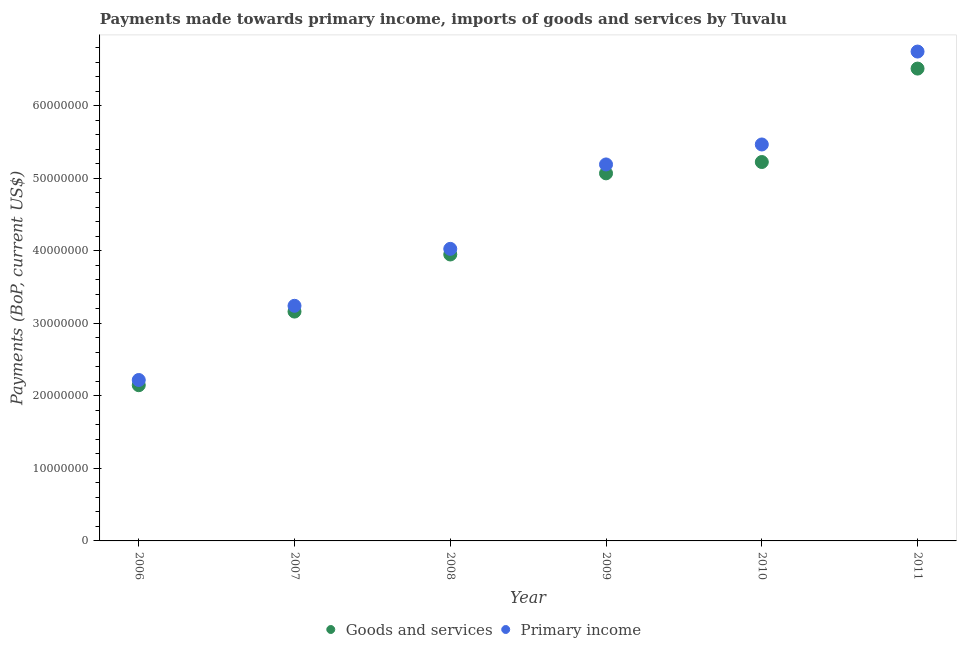How many different coloured dotlines are there?
Ensure brevity in your answer.  2. Is the number of dotlines equal to the number of legend labels?
Your answer should be very brief. Yes. What is the payments made towards primary income in 2007?
Provide a succinct answer. 3.24e+07. Across all years, what is the maximum payments made towards goods and services?
Your answer should be very brief. 6.51e+07. Across all years, what is the minimum payments made towards primary income?
Ensure brevity in your answer.  2.22e+07. In which year was the payments made towards goods and services maximum?
Provide a short and direct response. 2011. In which year was the payments made towards primary income minimum?
Offer a very short reply. 2006. What is the total payments made towards primary income in the graph?
Your answer should be compact. 2.69e+08. What is the difference between the payments made towards primary income in 2009 and that in 2011?
Ensure brevity in your answer.  -1.56e+07. What is the difference between the payments made towards primary income in 2007 and the payments made towards goods and services in 2008?
Keep it short and to the point. -7.08e+06. What is the average payments made towards primary income per year?
Your answer should be very brief. 4.48e+07. In the year 2007, what is the difference between the payments made towards primary income and payments made towards goods and services?
Provide a succinct answer. 7.97e+05. What is the ratio of the payments made towards primary income in 2008 to that in 2009?
Your response must be concise. 0.78. Is the payments made towards goods and services in 2006 less than that in 2010?
Your response must be concise. Yes. Is the difference between the payments made towards goods and services in 2006 and 2010 greater than the difference between the payments made towards primary income in 2006 and 2010?
Keep it short and to the point. Yes. What is the difference between the highest and the second highest payments made towards primary income?
Provide a short and direct response. 1.28e+07. What is the difference between the highest and the lowest payments made towards primary income?
Offer a terse response. 4.53e+07. Is the sum of the payments made towards goods and services in 2008 and 2011 greater than the maximum payments made towards primary income across all years?
Your answer should be compact. Yes. Does the payments made towards primary income monotonically increase over the years?
Offer a terse response. Yes. Is the payments made towards goods and services strictly greater than the payments made towards primary income over the years?
Offer a very short reply. No. What is the difference between two consecutive major ticks on the Y-axis?
Your answer should be very brief. 1.00e+07. Are the values on the major ticks of Y-axis written in scientific E-notation?
Keep it short and to the point. No. Does the graph contain any zero values?
Provide a short and direct response. No. How many legend labels are there?
Keep it short and to the point. 2. What is the title of the graph?
Your response must be concise. Payments made towards primary income, imports of goods and services by Tuvalu. What is the label or title of the Y-axis?
Make the answer very short. Payments (BoP, current US$). What is the Payments (BoP, current US$) of Goods and services in 2006?
Keep it short and to the point. 2.15e+07. What is the Payments (BoP, current US$) in Primary income in 2006?
Your answer should be very brief. 2.22e+07. What is the Payments (BoP, current US$) in Goods and services in 2007?
Your response must be concise. 3.16e+07. What is the Payments (BoP, current US$) of Primary income in 2007?
Provide a succinct answer. 3.24e+07. What is the Payments (BoP, current US$) of Goods and services in 2008?
Your answer should be very brief. 3.95e+07. What is the Payments (BoP, current US$) of Primary income in 2008?
Provide a succinct answer. 4.03e+07. What is the Payments (BoP, current US$) of Goods and services in 2009?
Provide a short and direct response. 5.07e+07. What is the Payments (BoP, current US$) of Primary income in 2009?
Ensure brevity in your answer.  5.19e+07. What is the Payments (BoP, current US$) in Goods and services in 2010?
Your answer should be compact. 5.22e+07. What is the Payments (BoP, current US$) of Primary income in 2010?
Offer a very short reply. 5.47e+07. What is the Payments (BoP, current US$) of Goods and services in 2011?
Give a very brief answer. 6.51e+07. What is the Payments (BoP, current US$) in Primary income in 2011?
Your answer should be compact. 6.75e+07. Across all years, what is the maximum Payments (BoP, current US$) in Goods and services?
Keep it short and to the point. 6.51e+07. Across all years, what is the maximum Payments (BoP, current US$) in Primary income?
Make the answer very short. 6.75e+07. Across all years, what is the minimum Payments (BoP, current US$) in Goods and services?
Provide a short and direct response. 2.15e+07. Across all years, what is the minimum Payments (BoP, current US$) of Primary income?
Give a very brief answer. 2.22e+07. What is the total Payments (BoP, current US$) of Goods and services in the graph?
Make the answer very short. 2.61e+08. What is the total Payments (BoP, current US$) of Primary income in the graph?
Provide a short and direct response. 2.69e+08. What is the difference between the Payments (BoP, current US$) of Goods and services in 2006 and that in 2007?
Make the answer very short. -1.02e+07. What is the difference between the Payments (BoP, current US$) in Primary income in 2006 and that in 2007?
Ensure brevity in your answer.  -1.02e+07. What is the difference between the Payments (BoP, current US$) in Goods and services in 2006 and that in 2008?
Make the answer very short. -1.80e+07. What is the difference between the Payments (BoP, current US$) of Primary income in 2006 and that in 2008?
Provide a succinct answer. -1.81e+07. What is the difference between the Payments (BoP, current US$) in Goods and services in 2006 and that in 2009?
Your answer should be very brief. -2.92e+07. What is the difference between the Payments (BoP, current US$) of Primary income in 2006 and that in 2009?
Provide a succinct answer. -2.97e+07. What is the difference between the Payments (BoP, current US$) in Goods and services in 2006 and that in 2010?
Keep it short and to the point. -3.08e+07. What is the difference between the Payments (BoP, current US$) in Primary income in 2006 and that in 2010?
Your response must be concise. -3.25e+07. What is the difference between the Payments (BoP, current US$) in Goods and services in 2006 and that in 2011?
Offer a very short reply. -4.37e+07. What is the difference between the Payments (BoP, current US$) in Primary income in 2006 and that in 2011?
Offer a terse response. -4.53e+07. What is the difference between the Payments (BoP, current US$) in Goods and services in 2007 and that in 2008?
Provide a short and direct response. -7.87e+06. What is the difference between the Payments (BoP, current US$) of Primary income in 2007 and that in 2008?
Your answer should be compact. -7.85e+06. What is the difference between the Payments (BoP, current US$) in Goods and services in 2007 and that in 2009?
Provide a succinct answer. -1.91e+07. What is the difference between the Payments (BoP, current US$) of Primary income in 2007 and that in 2009?
Provide a succinct answer. -1.95e+07. What is the difference between the Payments (BoP, current US$) in Goods and services in 2007 and that in 2010?
Provide a short and direct response. -2.06e+07. What is the difference between the Payments (BoP, current US$) in Primary income in 2007 and that in 2010?
Provide a succinct answer. -2.22e+07. What is the difference between the Payments (BoP, current US$) in Goods and services in 2007 and that in 2011?
Your answer should be very brief. -3.35e+07. What is the difference between the Payments (BoP, current US$) of Primary income in 2007 and that in 2011?
Your response must be concise. -3.51e+07. What is the difference between the Payments (BoP, current US$) in Goods and services in 2008 and that in 2009?
Offer a very short reply. -1.12e+07. What is the difference between the Payments (BoP, current US$) of Primary income in 2008 and that in 2009?
Offer a very short reply. -1.16e+07. What is the difference between the Payments (BoP, current US$) in Goods and services in 2008 and that in 2010?
Give a very brief answer. -1.27e+07. What is the difference between the Payments (BoP, current US$) of Primary income in 2008 and that in 2010?
Your answer should be very brief. -1.44e+07. What is the difference between the Payments (BoP, current US$) of Goods and services in 2008 and that in 2011?
Provide a succinct answer. -2.56e+07. What is the difference between the Payments (BoP, current US$) of Primary income in 2008 and that in 2011?
Your answer should be very brief. -2.72e+07. What is the difference between the Payments (BoP, current US$) in Goods and services in 2009 and that in 2010?
Provide a short and direct response. -1.56e+06. What is the difference between the Payments (BoP, current US$) of Primary income in 2009 and that in 2010?
Provide a short and direct response. -2.75e+06. What is the difference between the Payments (BoP, current US$) in Goods and services in 2009 and that in 2011?
Your answer should be compact. -1.44e+07. What is the difference between the Payments (BoP, current US$) of Primary income in 2009 and that in 2011?
Offer a very short reply. -1.56e+07. What is the difference between the Payments (BoP, current US$) in Goods and services in 2010 and that in 2011?
Keep it short and to the point. -1.29e+07. What is the difference between the Payments (BoP, current US$) in Primary income in 2010 and that in 2011?
Offer a terse response. -1.28e+07. What is the difference between the Payments (BoP, current US$) of Goods and services in 2006 and the Payments (BoP, current US$) of Primary income in 2007?
Your answer should be compact. -1.09e+07. What is the difference between the Payments (BoP, current US$) in Goods and services in 2006 and the Payments (BoP, current US$) in Primary income in 2008?
Keep it short and to the point. -1.88e+07. What is the difference between the Payments (BoP, current US$) of Goods and services in 2006 and the Payments (BoP, current US$) of Primary income in 2009?
Your response must be concise. -3.04e+07. What is the difference between the Payments (BoP, current US$) of Goods and services in 2006 and the Payments (BoP, current US$) of Primary income in 2010?
Provide a short and direct response. -3.32e+07. What is the difference between the Payments (BoP, current US$) in Goods and services in 2006 and the Payments (BoP, current US$) in Primary income in 2011?
Offer a terse response. -4.60e+07. What is the difference between the Payments (BoP, current US$) in Goods and services in 2007 and the Payments (BoP, current US$) in Primary income in 2008?
Keep it short and to the point. -8.65e+06. What is the difference between the Payments (BoP, current US$) of Goods and services in 2007 and the Payments (BoP, current US$) of Primary income in 2009?
Make the answer very short. -2.03e+07. What is the difference between the Payments (BoP, current US$) of Goods and services in 2007 and the Payments (BoP, current US$) of Primary income in 2010?
Provide a short and direct response. -2.30e+07. What is the difference between the Payments (BoP, current US$) in Goods and services in 2007 and the Payments (BoP, current US$) in Primary income in 2011?
Your response must be concise. -3.59e+07. What is the difference between the Payments (BoP, current US$) in Goods and services in 2008 and the Payments (BoP, current US$) in Primary income in 2009?
Ensure brevity in your answer.  -1.24e+07. What is the difference between the Payments (BoP, current US$) of Goods and services in 2008 and the Payments (BoP, current US$) of Primary income in 2010?
Offer a very short reply. -1.52e+07. What is the difference between the Payments (BoP, current US$) in Goods and services in 2008 and the Payments (BoP, current US$) in Primary income in 2011?
Provide a short and direct response. -2.80e+07. What is the difference between the Payments (BoP, current US$) in Goods and services in 2009 and the Payments (BoP, current US$) in Primary income in 2010?
Offer a very short reply. -3.98e+06. What is the difference between the Payments (BoP, current US$) of Goods and services in 2009 and the Payments (BoP, current US$) of Primary income in 2011?
Offer a very short reply. -1.68e+07. What is the difference between the Payments (BoP, current US$) of Goods and services in 2010 and the Payments (BoP, current US$) of Primary income in 2011?
Keep it short and to the point. -1.52e+07. What is the average Payments (BoP, current US$) of Goods and services per year?
Give a very brief answer. 4.34e+07. What is the average Payments (BoP, current US$) of Primary income per year?
Your response must be concise. 4.48e+07. In the year 2006, what is the difference between the Payments (BoP, current US$) in Goods and services and Payments (BoP, current US$) in Primary income?
Ensure brevity in your answer.  -7.17e+05. In the year 2007, what is the difference between the Payments (BoP, current US$) of Goods and services and Payments (BoP, current US$) of Primary income?
Make the answer very short. -7.97e+05. In the year 2008, what is the difference between the Payments (BoP, current US$) in Goods and services and Payments (BoP, current US$) in Primary income?
Offer a very short reply. -7.76e+05. In the year 2009, what is the difference between the Payments (BoP, current US$) of Goods and services and Payments (BoP, current US$) of Primary income?
Make the answer very short. -1.23e+06. In the year 2010, what is the difference between the Payments (BoP, current US$) of Goods and services and Payments (BoP, current US$) of Primary income?
Keep it short and to the point. -2.42e+06. In the year 2011, what is the difference between the Payments (BoP, current US$) of Goods and services and Payments (BoP, current US$) of Primary income?
Offer a very short reply. -2.35e+06. What is the ratio of the Payments (BoP, current US$) of Goods and services in 2006 to that in 2007?
Your response must be concise. 0.68. What is the ratio of the Payments (BoP, current US$) in Primary income in 2006 to that in 2007?
Ensure brevity in your answer.  0.68. What is the ratio of the Payments (BoP, current US$) of Goods and services in 2006 to that in 2008?
Your response must be concise. 0.54. What is the ratio of the Payments (BoP, current US$) of Primary income in 2006 to that in 2008?
Provide a succinct answer. 0.55. What is the ratio of the Payments (BoP, current US$) in Goods and services in 2006 to that in 2009?
Provide a succinct answer. 0.42. What is the ratio of the Payments (BoP, current US$) in Primary income in 2006 to that in 2009?
Provide a succinct answer. 0.43. What is the ratio of the Payments (BoP, current US$) of Goods and services in 2006 to that in 2010?
Give a very brief answer. 0.41. What is the ratio of the Payments (BoP, current US$) in Primary income in 2006 to that in 2010?
Give a very brief answer. 0.41. What is the ratio of the Payments (BoP, current US$) in Goods and services in 2006 to that in 2011?
Give a very brief answer. 0.33. What is the ratio of the Payments (BoP, current US$) of Primary income in 2006 to that in 2011?
Offer a very short reply. 0.33. What is the ratio of the Payments (BoP, current US$) in Goods and services in 2007 to that in 2008?
Make the answer very short. 0.8. What is the ratio of the Payments (BoP, current US$) in Primary income in 2007 to that in 2008?
Keep it short and to the point. 0.81. What is the ratio of the Payments (BoP, current US$) of Goods and services in 2007 to that in 2009?
Keep it short and to the point. 0.62. What is the ratio of the Payments (BoP, current US$) of Primary income in 2007 to that in 2009?
Make the answer very short. 0.62. What is the ratio of the Payments (BoP, current US$) of Goods and services in 2007 to that in 2010?
Offer a very short reply. 0.61. What is the ratio of the Payments (BoP, current US$) in Primary income in 2007 to that in 2010?
Your answer should be very brief. 0.59. What is the ratio of the Payments (BoP, current US$) of Goods and services in 2007 to that in 2011?
Offer a terse response. 0.49. What is the ratio of the Payments (BoP, current US$) in Primary income in 2007 to that in 2011?
Your answer should be very brief. 0.48. What is the ratio of the Payments (BoP, current US$) of Goods and services in 2008 to that in 2009?
Offer a very short reply. 0.78. What is the ratio of the Payments (BoP, current US$) in Primary income in 2008 to that in 2009?
Your answer should be compact. 0.78. What is the ratio of the Payments (BoP, current US$) of Goods and services in 2008 to that in 2010?
Offer a very short reply. 0.76. What is the ratio of the Payments (BoP, current US$) of Primary income in 2008 to that in 2010?
Ensure brevity in your answer.  0.74. What is the ratio of the Payments (BoP, current US$) in Goods and services in 2008 to that in 2011?
Keep it short and to the point. 0.61. What is the ratio of the Payments (BoP, current US$) in Primary income in 2008 to that in 2011?
Your answer should be very brief. 0.6. What is the ratio of the Payments (BoP, current US$) in Goods and services in 2009 to that in 2010?
Provide a short and direct response. 0.97. What is the ratio of the Payments (BoP, current US$) of Primary income in 2009 to that in 2010?
Make the answer very short. 0.95. What is the ratio of the Payments (BoP, current US$) in Goods and services in 2009 to that in 2011?
Your answer should be very brief. 0.78. What is the ratio of the Payments (BoP, current US$) of Primary income in 2009 to that in 2011?
Your answer should be very brief. 0.77. What is the ratio of the Payments (BoP, current US$) in Goods and services in 2010 to that in 2011?
Give a very brief answer. 0.8. What is the ratio of the Payments (BoP, current US$) of Primary income in 2010 to that in 2011?
Ensure brevity in your answer.  0.81. What is the difference between the highest and the second highest Payments (BoP, current US$) of Goods and services?
Offer a terse response. 1.29e+07. What is the difference between the highest and the second highest Payments (BoP, current US$) of Primary income?
Your answer should be very brief. 1.28e+07. What is the difference between the highest and the lowest Payments (BoP, current US$) in Goods and services?
Make the answer very short. 4.37e+07. What is the difference between the highest and the lowest Payments (BoP, current US$) of Primary income?
Your response must be concise. 4.53e+07. 